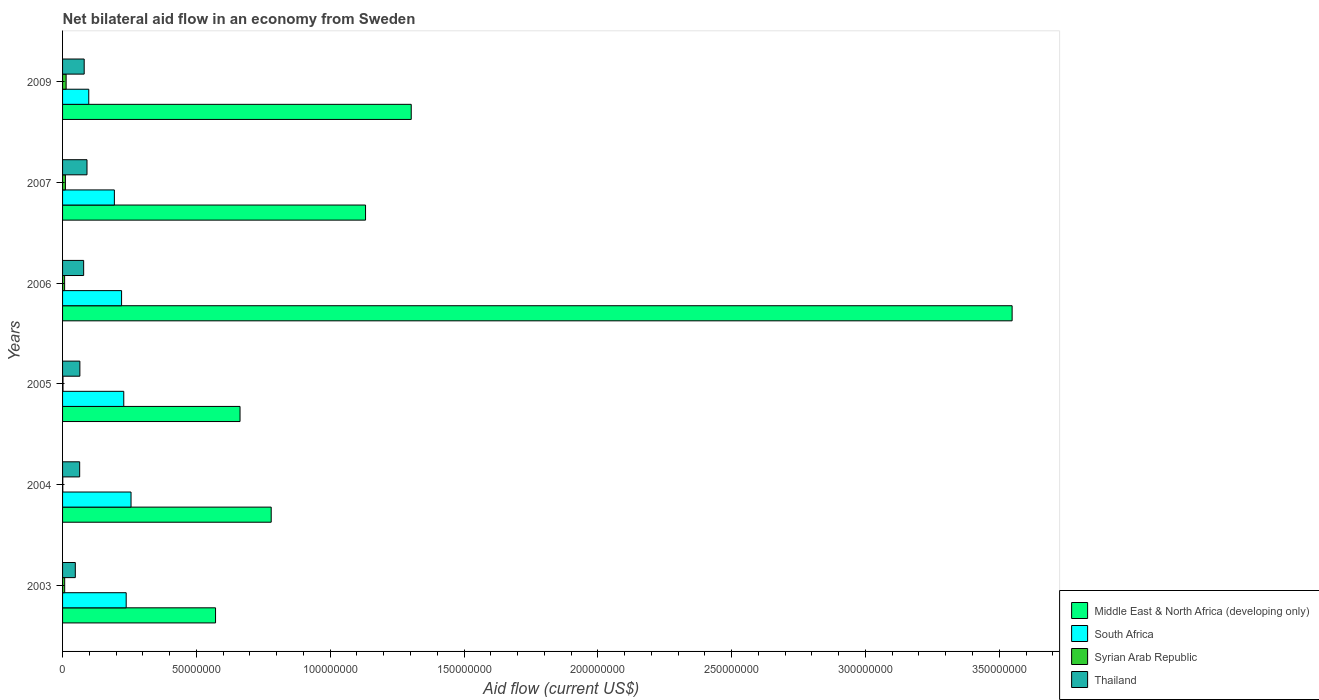How many different coloured bars are there?
Give a very brief answer. 4. Are the number of bars on each tick of the Y-axis equal?
Make the answer very short. Yes. What is the net bilateral aid flow in Middle East & North Africa (developing only) in 2004?
Offer a very short reply. 7.80e+07. Across all years, what is the maximum net bilateral aid flow in Syrian Arab Republic?
Your answer should be compact. 1.33e+06. Across all years, what is the minimum net bilateral aid flow in Syrian Arab Republic?
Offer a very short reply. 8.00e+04. In which year was the net bilateral aid flow in Syrian Arab Republic maximum?
Keep it short and to the point. 2009. In which year was the net bilateral aid flow in Middle East & North Africa (developing only) minimum?
Offer a very short reply. 2003. What is the total net bilateral aid flow in South Africa in the graph?
Keep it short and to the point. 1.23e+08. What is the difference between the net bilateral aid flow in Middle East & North Africa (developing only) in 2003 and that in 2007?
Give a very brief answer. -5.60e+07. What is the difference between the net bilateral aid flow in Middle East & North Africa (developing only) in 2004 and the net bilateral aid flow in Syrian Arab Republic in 2005?
Offer a terse response. 7.78e+07. What is the average net bilateral aid flow in Middle East & North Africa (developing only) per year?
Offer a very short reply. 1.33e+08. In the year 2003, what is the difference between the net bilateral aid flow in Thailand and net bilateral aid flow in Syrian Arab Republic?
Offer a terse response. 3.97e+06. What is the ratio of the net bilateral aid flow in Middle East & North Africa (developing only) in 2004 to that in 2009?
Your response must be concise. 0.6. Is the difference between the net bilateral aid flow in Thailand in 2004 and 2005 greater than the difference between the net bilateral aid flow in Syrian Arab Republic in 2004 and 2005?
Keep it short and to the point. No. What is the difference between the highest and the second highest net bilateral aid flow in South Africa?
Keep it short and to the point. 1.81e+06. What is the difference between the highest and the lowest net bilateral aid flow in Thailand?
Provide a succinct answer. 4.37e+06. Is it the case that in every year, the sum of the net bilateral aid flow in Syrian Arab Republic and net bilateral aid flow in Middle East & North Africa (developing only) is greater than the sum of net bilateral aid flow in Thailand and net bilateral aid flow in South Africa?
Make the answer very short. Yes. What does the 3rd bar from the top in 2003 represents?
Ensure brevity in your answer.  South Africa. What does the 3rd bar from the bottom in 2006 represents?
Your answer should be compact. Syrian Arab Republic. Is it the case that in every year, the sum of the net bilateral aid flow in Middle East & North Africa (developing only) and net bilateral aid flow in South Africa is greater than the net bilateral aid flow in Syrian Arab Republic?
Ensure brevity in your answer.  Yes. How many years are there in the graph?
Provide a short and direct response. 6. Does the graph contain any zero values?
Give a very brief answer. No. Where does the legend appear in the graph?
Make the answer very short. Bottom right. What is the title of the graph?
Provide a succinct answer. Net bilateral aid flow in an economy from Sweden. Does "Somalia" appear as one of the legend labels in the graph?
Your answer should be compact. No. What is the label or title of the X-axis?
Make the answer very short. Aid flow (current US$). What is the Aid flow (current US$) of Middle East & North Africa (developing only) in 2003?
Your response must be concise. 5.72e+07. What is the Aid flow (current US$) in South Africa in 2003?
Offer a very short reply. 2.38e+07. What is the Aid flow (current US$) in Syrian Arab Republic in 2003?
Offer a very short reply. 7.90e+05. What is the Aid flow (current US$) of Thailand in 2003?
Keep it short and to the point. 4.76e+06. What is the Aid flow (current US$) in Middle East & North Africa (developing only) in 2004?
Your answer should be compact. 7.80e+07. What is the Aid flow (current US$) of South Africa in 2004?
Your answer should be very brief. 2.56e+07. What is the Aid flow (current US$) in Syrian Arab Republic in 2004?
Provide a succinct answer. 8.00e+04. What is the Aid flow (current US$) of Thailand in 2004?
Your answer should be very brief. 6.39e+06. What is the Aid flow (current US$) in Middle East & North Africa (developing only) in 2005?
Offer a very short reply. 6.63e+07. What is the Aid flow (current US$) in South Africa in 2005?
Offer a very short reply. 2.29e+07. What is the Aid flow (current US$) in Thailand in 2005?
Provide a succinct answer. 6.47e+06. What is the Aid flow (current US$) in Middle East & North Africa (developing only) in 2006?
Offer a terse response. 3.55e+08. What is the Aid flow (current US$) of South Africa in 2006?
Offer a very short reply. 2.20e+07. What is the Aid flow (current US$) in Syrian Arab Republic in 2006?
Your response must be concise. 7.70e+05. What is the Aid flow (current US$) in Thailand in 2006?
Provide a succinct answer. 7.88e+06. What is the Aid flow (current US$) of Middle East & North Africa (developing only) in 2007?
Give a very brief answer. 1.13e+08. What is the Aid flow (current US$) in South Africa in 2007?
Your answer should be very brief. 1.94e+07. What is the Aid flow (current US$) in Syrian Arab Republic in 2007?
Ensure brevity in your answer.  1.06e+06. What is the Aid flow (current US$) in Thailand in 2007?
Your answer should be compact. 9.13e+06. What is the Aid flow (current US$) of Middle East & North Africa (developing only) in 2009?
Provide a short and direct response. 1.30e+08. What is the Aid flow (current US$) of South Africa in 2009?
Your answer should be very brief. 9.79e+06. What is the Aid flow (current US$) in Syrian Arab Republic in 2009?
Your response must be concise. 1.33e+06. What is the Aid flow (current US$) of Thailand in 2009?
Provide a succinct answer. 8.08e+06. Across all years, what is the maximum Aid flow (current US$) in Middle East & North Africa (developing only)?
Provide a succinct answer. 3.55e+08. Across all years, what is the maximum Aid flow (current US$) of South Africa?
Your answer should be compact. 2.56e+07. Across all years, what is the maximum Aid flow (current US$) of Syrian Arab Republic?
Offer a terse response. 1.33e+06. Across all years, what is the maximum Aid flow (current US$) of Thailand?
Your response must be concise. 9.13e+06. Across all years, what is the minimum Aid flow (current US$) in Middle East & North Africa (developing only)?
Provide a short and direct response. 5.72e+07. Across all years, what is the minimum Aid flow (current US$) in South Africa?
Your response must be concise. 9.79e+06. Across all years, what is the minimum Aid flow (current US$) of Syrian Arab Republic?
Offer a terse response. 8.00e+04. Across all years, what is the minimum Aid flow (current US$) in Thailand?
Offer a very short reply. 4.76e+06. What is the total Aid flow (current US$) of Middle East & North Africa (developing only) in the graph?
Offer a very short reply. 8.00e+08. What is the total Aid flow (current US$) in South Africa in the graph?
Your answer should be compact. 1.23e+08. What is the total Aid flow (current US$) in Syrian Arab Republic in the graph?
Provide a succinct answer. 4.19e+06. What is the total Aid flow (current US$) of Thailand in the graph?
Ensure brevity in your answer.  4.27e+07. What is the difference between the Aid flow (current US$) in Middle East & North Africa (developing only) in 2003 and that in 2004?
Offer a terse response. -2.08e+07. What is the difference between the Aid flow (current US$) in South Africa in 2003 and that in 2004?
Your response must be concise. -1.81e+06. What is the difference between the Aid flow (current US$) of Syrian Arab Republic in 2003 and that in 2004?
Your answer should be compact. 7.10e+05. What is the difference between the Aid flow (current US$) of Thailand in 2003 and that in 2004?
Your answer should be compact. -1.63e+06. What is the difference between the Aid flow (current US$) in Middle East & North Africa (developing only) in 2003 and that in 2005?
Keep it short and to the point. -9.15e+06. What is the difference between the Aid flow (current US$) of South Africa in 2003 and that in 2005?
Provide a short and direct response. 9.00e+05. What is the difference between the Aid flow (current US$) of Syrian Arab Republic in 2003 and that in 2005?
Offer a very short reply. 6.30e+05. What is the difference between the Aid flow (current US$) in Thailand in 2003 and that in 2005?
Your response must be concise. -1.71e+06. What is the difference between the Aid flow (current US$) of Middle East & North Africa (developing only) in 2003 and that in 2006?
Provide a short and direct response. -2.98e+08. What is the difference between the Aid flow (current US$) in South Africa in 2003 and that in 2006?
Provide a succinct answer. 1.72e+06. What is the difference between the Aid flow (current US$) in Thailand in 2003 and that in 2006?
Make the answer very short. -3.12e+06. What is the difference between the Aid flow (current US$) in Middle East & North Africa (developing only) in 2003 and that in 2007?
Keep it short and to the point. -5.60e+07. What is the difference between the Aid flow (current US$) of South Africa in 2003 and that in 2007?
Make the answer very short. 4.41e+06. What is the difference between the Aid flow (current US$) of Syrian Arab Republic in 2003 and that in 2007?
Your answer should be compact. -2.70e+05. What is the difference between the Aid flow (current US$) in Thailand in 2003 and that in 2007?
Keep it short and to the point. -4.37e+06. What is the difference between the Aid flow (current US$) of Middle East & North Africa (developing only) in 2003 and that in 2009?
Make the answer very short. -7.31e+07. What is the difference between the Aid flow (current US$) in South Africa in 2003 and that in 2009?
Ensure brevity in your answer.  1.40e+07. What is the difference between the Aid flow (current US$) of Syrian Arab Republic in 2003 and that in 2009?
Ensure brevity in your answer.  -5.40e+05. What is the difference between the Aid flow (current US$) in Thailand in 2003 and that in 2009?
Make the answer very short. -3.32e+06. What is the difference between the Aid flow (current US$) of Middle East & North Africa (developing only) in 2004 and that in 2005?
Keep it short and to the point. 1.16e+07. What is the difference between the Aid flow (current US$) in South Africa in 2004 and that in 2005?
Ensure brevity in your answer.  2.71e+06. What is the difference between the Aid flow (current US$) of Middle East & North Africa (developing only) in 2004 and that in 2006?
Ensure brevity in your answer.  -2.77e+08. What is the difference between the Aid flow (current US$) in South Africa in 2004 and that in 2006?
Provide a succinct answer. 3.53e+06. What is the difference between the Aid flow (current US$) of Syrian Arab Republic in 2004 and that in 2006?
Keep it short and to the point. -6.90e+05. What is the difference between the Aid flow (current US$) of Thailand in 2004 and that in 2006?
Your answer should be compact. -1.49e+06. What is the difference between the Aid flow (current US$) in Middle East & North Africa (developing only) in 2004 and that in 2007?
Your response must be concise. -3.52e+07. What is the difference between the Aid flow (current US$) in South Africa in 2004 and that in 2007?
Give a very brief answer. 6.22e+06. What is the difference between the Aid flow (current US$) in Syrian Arab Republic in 2004 and that in 2007?
Your response must be concise. -9.80e+05. What is the difference between the Aid flow (current US$) of Thailand in 2004 and that in 2007?
Provide a succinct answer. -2.74e+06. What is the difference between the Aid flow (current US$) in Middle East & North Africa (developing only) in 2004 and that in 2009?
Provide a short and direct response. -5.23e+07. What is the difference between the Aid flow (current US$) of South Africa in 2004 and that in 2009?
Your answer should be very brief. 1.58e+07. What is the difference between the Aid flow (current US$) in Syrian Arab Republic in 2004 and that in 2009?
Ensure brevity in your answer.  -1.25e+06. What is the difference between the Aid flow (current US$) in Thailand in 2004 and that in 2009?
Your response must be concise. -1.69e+06. What is the difference between the Aid flow (current US$) of Middle East & North Africa (developing only) in 2005 and that in 2006?
Offer a very short reply. -2.88e+08. What is the difference between the Aid flow (current US$) in South Africa in 2005 and that in 2006?
Your answer should be compact. 8.20e+05. What is the difference between the Aid flow (current US$) of Syrian Arab Republic in 2005 and that in 2006?
Ensure brevity in your answer.  -6.10e+05. What is the difference between the Aid flow (current US$) in Thailand in 2005 and that in 2006?
Your response must be concise. -1.41e+06. What is the difference between the Aid flow (current US$) of Middle East & North Africa (developing only) in 2005 and that in 2007?
Provide a short and direct response. -4.69e+07. What is the difference between the Aid flow (current US$) in South Africa in 2005 and that in 2007?
Provide a succinct answer. 3.51e+06. What is the difference between the Aid flow (current US$) of Syrian Arab Republic in 2005 and that in 2007?
Your answer should be compact. -9.00e+05. What is the difference between the Aid flow (current US$) of Thailand in 2005 and that in 2007?
Your answer should be compact. -2.66e+06. What is the difference between the Aid flow (current US$) of Middle East & North Africa (developing only) in 2005 and that in 2009?
Keep it short and to the point. -6.40e+07. What is the difference between the Aid flow (current US$) of South Africa in 2005 and that in 2009?
Provide a succinct answer. 1.31e+07. What is the difference between the Aid flow (current US$) in Syrian Arab Republic in 2005 and that in 2009?
Provide a succinct answer. -1.17e+06. What is the difference between the Aid flow (current US$) in Thailand in 2005 and that in 2009?
Your response must be concise. -1.61e+06. What is the difference between the Aid flow (current US$) of Middle East & North Africa (developing only) in 2006 and that in 2007?
Keep it short and to the point. 2.42e+08. What is the difference between the Aid flow (current US$) of South Africa in 2006 and that in 2007?
Provide a short and direct response. 2.69e+06. What is the difference between the Aid flow (current US$) in Thailand in 2006 and that in 2007?
Provide a succinct answer. -1.25e+06. What is the difference between the Aid flow (current US$) in Middle East & North Africa (developing only) in 2006 and that in 2009?
Your response must be concise. 2.25e+08. What is the difference between the Aid flow (current US$) of South Africa in 2006 and that in 2009?
Your response must be concise. 1.23e+07. What is the difference between the Aid flow (current US$) in Syrian Arab Republic in 2006 and that in 2009?
Provide a short and direct response. -5.60e+05. What is the difference between the Aid flow (current US$) of Middle East & North Africa (developing only) in 2007 and that in 2009?
Give a very brief answer. -1.71e+07. What is the difference between the Aid flow (current US$) of South Africa in 2007 and that in 2009?
Give a very brief answer. 9.57e+06. What is the difference between the Aid flow (current US$) of Syrian Arab Republic in 2007 and that in 2009?
Keep it short and to the point. -2.70e+05. What is the difference between the Aid flow (current US$) of Thailand in 2007 and that in 2009?
Keep it short and to the point. 1.05e+06. What is the difference between the Aid flow (current US$) in Middle East & North Africa (developing only) in 2003 and the Aid flow (current US$) in South Africa in 2004?
Offer a very short reply. 3.16e+07. What is the difference between the Aid flow (current US$) in Middle East & North Africa (developing only) in 2003 and the Aid flow (current US$) in Syrian Arab Republic in 2004?
Offer a terse response. 5.71e+07. What is the difference between the Aid flow (current US$) in Middle East & North Africa (developing only) in 2003 and the Aid flow (current US$) in Thailand in 2004?
Offer a very short reply. 5.08e+07. What is the difference between the Aid flow (current US$) of South Africa in 2003 and the Aid flow (current US$) of Syrian Arab Republic in 2004?
Your response must be concise. 2.37e+07. What is the difference between the Aid flow (current US$) of South Africa in 2003 and the Aid flow (current US$) of Thailand in 2004?
Your answer should be very brief. 1.74e+07. What is the difference between the Aid flow (current US$) of Syrian Arab Republic in 2003 and the Aid flow (current US$) of Thailand in 2004?
Ensure brevity in your answer.  -5.60e+06. What is the difference between the Aid flow (current US$) of Middle East & North Africa (developing only) in 2003 and the Aid flow (current US$) of South Africa in 2005?
Provide a short and direct response. 3.43e+07. What is the difference between the Aid flow (current US$) in Middle East & North Africa (developing only) in 2003 and the Aid flow (current US$) in Syrian Arab Republic in 2005?
Your answer should be very brief. 5.70e+07. What is the difference between the Aid flow (current US$) of Middle East & North Africa (developing only) in 2003 and the Aid flow (current US$) of Thailand in 2005?
Your answer should be compact. 5.07e+07. What is the difference between the Aid flow (current US$) of South Africa in 2003 and the Aid flow (current US$) of Syrian Arab Republic in 2005?
Your response must be concise. 2.36e+07. What is the difference between the Aid flow (current US$) in South Africa in 2003 and the Aid flow (current US$) in Thailand in 2005?
Make the answer very short. 1.73e+07. What is the difference between the Aid flow (current US$) in Syrian Arab Republic in 2003 and the Aid flow (current US$) in Thailand in 2005?
Offer a terse response. -5.68e+06. What is the difference between the Aid flow (current US$) in Middle East & North Africa (developing only) in 2003 and the Aid flow (current US$) in South Africa in 2006?
Your answer should be very brief. 3.51e+07. What is the difference between the Aid flow (current US$) in Middle East & North Africa (developing only) in 2003 and the Aid flow (current US$) in Syrian Arab Republic in 2006?
Provide a short and direct response. 5.64e+07. What is the difference between the Aid flow (current US$) of Middle East & North Africa (developing only) in 2003 and the Aid flow (current US$) of Thailand in 2006?
Give a very brief answer. 4.93e+07. What is the difference between the Aid flow (current US$) of South Africa in 2003 and the Aid flow (current US$) of Syrian Arab Republic in 2006?
Provide a succinct answer. 2.30e+07. What is the difference between the Aid flow (current US$) of South Africa in 2003 and the Aid flow (current US$) of Thailand in 2006?
Offer a very short reply. 1.59e+07. What is the difference between the Aid flow (current US$) of Syrian Arab Republic in 2003 and the Aid flow (current US$) of Thailand in 2006?
Your answer should be very brief. -7.09e+06. What is the difference between the Aid flow (current US$) in Middle East & North Africa (developing only) in 2003 and the Aid flow (current US$) in South Africa in 2007?
Keep it short and to the point. 3.78e+07. What is the difference between the Aid flow (current US$) of Middle East & North Africa (developing only) in 2003 and the Aid flow (current US$) of Syrian Arab Republic in 2007?
Ensure brevity in your answer.  5.61e+07. What is the difference between the Aid flow (current US$) of Middle East & North Africa (developing only) in 2003 and the Aid flow (current US$) of Thailand in 2007?
Offer a terse response. 4.80e+07. What is the difference between the Aid flow (current US$) of South Africa in 2003 and the Aid flow (current US$) of Syrian Arab Republic in 2007?
Make the answer very short. 2.27e+07. What is the difference between the Aid flow (current US$) in South Africa in 2003 and the Aid flow (current US$) in Thailand in 2007?
Ensure brevity in your answer.  1.46e+07. What is the difference between the Aid flow (current US$) of Syrian Arab Republic in 2003 and the Aid flow (current US$) of Thailand in 2007?
Provide a succinct answer. -8.34e+06. What is the difference between the Aid flow (current US$) in Middle East & North Africa (developing only) in 2003 and the Aid flow (current US$) in South Africa in 2009?
Provide a succinct answer. 4.74e+07. What is the difference between the Aid flow (current US$) of Middle East & North Africa (developing only) in 2003 and the Aid flow (current US$) of Syrian Arab Republic in 2009?
Offer a very short reply. 5.58e+07. What is the difference between the Aid flow (current US$) of Middle East & North Africa (developing only) in 2003 and the Aid flow (current US$) of Thailand in 2009?
Your answer should be compact. 4.91e+07. What is the difference between the Aid flow (current US$) of South Africa in 2003 and the Aid flow (current US$) of Syrian Arab Republic in 2009?
Give a very brief answer. 2.24e+07. What is the difference between the Aid flow (current US$) in South Africa in 2003 and the Aid flow (current US$) in Thailand in 2009?
Provide a short and direct response. 1.57e+07. What is the difference between the Aid flow (current US$) of Syrian Arab Republic in 2003 and the Aid flow (current US$) of Thailand in 2009?
Offer a terse response. -7.29e+06. What is the difference between the Aid flow (current US$) in Middle East & North Africa (developing only) in 2004 and the Aid flow (current US$) in South Africa in 2005?
Keep it short and to the point. 5.51e+07. What is the difference between the Aid flow (current US$) in Middle East & North Africa (developing only) in 2004 and the Aid flow (current US$) in Syrian Arab Republic in 2005?
Your answer should be very brief. 7.78e+07. What is the difference between the Aid flow (current US$) in Middle East & North Africa (developing only) in 2004 and the Aid flow (current US$) in Thailand in 2005?
Your answer should be very brief. 7.15e+07. What is the difference between the Aid flow (current US$) in South Africa in 2004 and the Aid flow (current US$) in Syrian Arab Republic in 2005?
Offer a terse response. 2.54e+07. What is the difference between the Aid flow (current US$) in South Africa in 2004 and the Aid flow (current US$) in Thailand in 2005?
Make the answer very short. 1.91e+07. What is the difference between the Aid flow (current US$) in Syrian Arab Republic in 2004 and the Aid flow (current US$) in Thailand in 2005?
Give a very brief answer. -6.39e+06. What is the difference between the Aid flow (current US$) of Middle East & North Africa (developing only) in 2004 and the Aid flow (current US$) of South Africa in 2006?
Your answer should be very brief. 5.59e+07. What is the difference between the Aid flow (current US$) of Middle East & North Africa (developing only) in 2004 and the Aid flow (current US$) of Syrian Arab Republic in 2006?
Make the answer very short. 7.72e+07. What is the difference between the Aid flow (current US$) in Middle East & North Africa (developing only) in 2004 and the Aid flow (current US$) in Thailand in 2006?
Offer a very short reply. 7.01e+07. What is the difference between the Aid flow (current US$) of South Africa in 2004 and the Aid flow (current US$) of Syrian Arab Republic in 2006?
Your answer should be compact. 2.48e+07. What is the difference between the Aid flow (current US$) of South Africa in 2004 and the Aid flow (current US$) of Thailand in 2006?
Provide a succinct answer. 1.77e+07. What is the difference between the Aid flow (current US$) of Syrian Arab Republic in 2004 and the Aid flow (current US$) of Thailand in 2006?
Make the answer very short. -7.80e+06. What is the difference between the Aid flow (current US$) of Middle East & North Africa (developing only) in 2004 and the Aid flow (current US$) of South Africa in 2007?
Keep it short and to the point. 5.86e+07. What is the difference between the Aid flow (current US$) in Middle East & North Africa (developing only) in 2004 and the Aid flow (current US$) in Syrian Arab Republic in 2007?
Offer a very short reply. 7.69e+07. What is the difference between the Aid flow (current US$) of Middle East & North Africa (developing only) in 2004 and the Aid flow (current US$) of Thailand in 2007?
Your response must be concise. 6.88e+07. What is the difference between the Aid flow (current US$) of South Africa in 2004 and the Aid flow (current US$) of Syrian Arab Republic in 2007?
Ensure brevity in your answer.  2.45e+07. What is the difference between the Aid flow (current US$) in South Africa in 2004 and the Aid flow (current US$) in Thailand in 2007?
Your response must be concise. 1.64e+07. What is the difference between the Aid flow (current US$) in Syrian Arab Republic in 2004 and the Aid flow (current US$) in Thailand in 2007?
Keep it short and to the point. -9.05e+06. What is the difference between the Aid flow (current US$) of Middle East & North Africa (developing only) in 2004 and the Aid flow (current US$) of South Africa in 2009?
Provide a succinct answer. 6.82e+07. What is the difference between the Aid flow (current US$) of Middle East & North Africa (developing only) in 2004 and the Aid flow (current US$) of Syrian Arab Republic in 2009?
Give a very brief answer. 7.66e+07. What is the difference between the Aid flow (current US$) of Middle East & North Africa (developing only) in 2004 and the Aid flow (current US$) of Thailand in 2009?
Provide a short and direct response. 6.99e+07. What is the difference between the Aid flow (current US$) in South Africa in 2004 and the Aid flow (current US$) in Syrian Arab Republic in 2009?
Provide a succinct answer. 2.42e+07. What is the difference between the Aid flow (current US$) in South Africa in 2004 and the Aid flow (current US$) in Thailand in 2009?
Your answer should be compact. 1.75e+07. What is the difference between the Aid flow (current US$) in Syrian Arab Republic in 2004 and the Aid flow (current US$) in Thailand in 2009?
Give a very brief answer. -8.00e+06. What is the difference between the Aid flow (current US$) of Middle East & North Africa (developing only) in 2005 and the Aid flow (current US$) of South Africa in 2006?
Ensure brevity in your answer.  4.43e+07. What is the difference between the Aid flow (current US$) in Middle East & North Africa (developing only) in 2005 and the Aid flow (current US$) in Syrian Arab Republic in 2006?
Ensure brevity in your answer.  6.55e+07. What is the difference between the Aid flow (current US$) of Middle East & North Africa (developing only) in 2005 and the Aid flow (current US$) of Thailand in 2006?
Give a very brief answer. 5.84e+07. What is the difference between the Aid flow (current US$) in South Africa in 2005 and the Aid flow (current US$) in Syrian Arab Republic in 2006?
Your answer should be very brief. 2.21e+07. What is the difference between the Aid flow (current US$) of South Africa in 2005 and the Aid flow (current US$) of Thailand in 2006?
Offer a terse response. 1.50e+07. What is the difference between the Aid flow (current US$) in Syrian Arab Republic in 2005 and the Aid flow (current US$) in Thailand in 2006?
Your response must be concise. -7.72e+06. What is the difference between the Aid flow (current US$) in Middle East & North Africa (developing only) in 2005 and the Aid flow (current US$) in South Africa in 2007?
Offer a terse response. 4.70e+07. What is the difference between the Aid flow (current US$) in Middle East & North Africa (developing only) in 2005 and the Aid flow (current US$) in Syrian Arab Republic in 2007?
Make the answer very short. 6.52e+07. What is the difference between the Aid flow (current US$) in Middle East & North Africa (developing only) in 2005 and the Aid flow (current US$) in Thailand in 2007?
Offer a terse response. 5.72e+07. What is the difference between the Aid flow (current US$) of South Africa in 2005 and the Aid flow (current US$) of Syrian Arab Republic in 2007?
Offer a terse response. 2.18e+07. What is the difference between the Aid flow (current US$) of South Africa in 2005 and the Aid flow (current US$) of Thailand in 2007?
Offer a terse response. 1.37e+07. What is the difference between the Aid flow (current US$) in Syrian Arab Republic in 2005 and the Aid flow (current US$) in Thailand in 2007?
Offer a very short reply. -8.97e+06. What is the difference between the Aid flow (current US$) in Middle East & North Africa (developing only) in 2005 and the Aid flow (current US$) in South Africa in 2009?
Provide a short and direct response. 5.65e+07. What is the difference between the Aid flow (current US$) of Middle East & North Africa (developing only) in 2005 and the Aid flow (current US$) of Syrian Arab Republic in 2009?
Provide a succinct answer. 6.50e+07. What is the difference between the Aid flow (current US$) of Middle East & North Africa (developing only) in 2005 and the Aid flow (current US$) of Thailand in 2009?
Offer a terse response. 5.82e+07. What is the difference between the Aid flow (current US$) in South Africa in 2005 and the Aid flow (current US$) in Syrian Arab Republic in 2009?
Give a very brief answer. 2.15e+07. What is the difference between the Aid flow (current US$) in South Africa in 2005 and the Aid flow (current US$) in Thailand in 2009?
Your answer should be compact. 1.48e+07. What is the difference between the Aid flow (current US$) of Syrian Arab Republic in 2005 and the Aid flow (current US$) of Thailand in 2009?
Your answer should be very brief. -7.92e+06. What is the difference between the Aid flow (current US$) in Middle East & North Africa (developing only) in 2006 and the Aid flow (current US$) in South Africa in 2007?
Keep it short and to the point. 3.35e+08. What is the difference between the Aid flow (current US$) in Middle East & North Africa (developing only) in 2006 and the Aid flow (current US$) in Syrian Arab Republic in 2007?
Provide a succinct answer. 3.54e+08. What is the difference between the Aid flow (current US$) in Middle East & North Africa (developing only) in 2006 and the Aid flow (current US$) in Thailand in 2007?
Provide a short and direct response. 3.46e+08. What is the difference between the Aid flow (current US$) of South Africa in 2006 and the Aid flow (current US$) of Syrian Arab Republic in 2007?
Ensure brevity in your answer.  2.10e+07. What is the difference between the Aid flow (current US$) of South Africa in 2006 and the Aid flow (current US$) of Thailand in 2007?
Ensure brevity in your answer.  1.29e+07. What is the difference between the Aid flow (current US$) of Syrian Arab Republic in 2006 and the Aid flow (current US$) of Thailand in 2007?
Offer a very short reply. -8.36e+06. What is the difference between the Aid flow (current US$) in Middle East & North Africa (developing only) in 2006 and the Aid flow (current US$) in South Africa in 2009?
Your response must be concise. 3.45e+08. What is the difference between the Aid flow (current US$) in Middle East & North Africa (developing only) in 2006 and the Aid flow (current US$) in Syrian Arab Republic in 2009?
Your answer should be compact. 3.53e+08. What is the difference between the Aid flow (current US$) in Middle East & North Africa (developing only) in 2006 and the Aid flow (current US$) in Thailand in 2009?
Keep it short and to the point. 3.47e+08. What is the difference between the Aid flow (current US$) of South Africa in 2006 and the Aid flow (current US$) of Syrian Arab Republic in 2009?
Ensure brevity in your answer.  2.07e+07. What is the difference between the Aid flow (current US$) of South Africa in 2006 and the Aid flow (current US$) of Thailand in 2009?
Your answer should be compact. 1.40e+07. What is the difference between the Aid flow (current US$) in Syrian Arab Republic in 2006 and the Aid flow (current US$) in Thailand in 2009?
Provide a short and direct response. -7.31e+06. What is the difference between the Aid flow (current US$) of Middle East & North Africa (developing only) in 2007 and the Aid flow (current US$) of South Africa in 2009?
Provide a short and direct response. 1.03e+08. What is the difference between the Aid flow (current US$) of Middle East & North Africa (developing only) in 2007 and the Aid flow (current US$) of Syrian Arab Republic in 2009?
Your answer should be compact. 1.12e+08. What is the difference between the Aid flow (current US$) in Middle East & North Africa (developing only) in 2007 and the Aid flow (current US$) in Thailand in 2009?
Keep it short and to the point. 1.05e+08. What is the difference between the Aid flow (current US$) of South Africa in 2007 and the Aid flow (current US$) of Syrian Arab Republic in 2009?
Your answer should be compact. 1.80e+07. What is the difference between the Aid flow (current US$) of South Africa in 2007 and the Aid flow (current US$) of Thailand in 2009?
Your answer should be compact. 1.13e+07. What is the difference between the Aid flow (current US$) in Syrian Arab Republic in 2007 and the Aid flow (current US$) in Thailand in 2009?
Give a very brief answer. -7.02e+06. What is the average Aid flow (current US$) in Middle East & North Africa (developing only) per year?
Keep it short and to the point. 1.33e+08. What is the average Aid flow (current US$) in South Africa per year?
Your answer should be very brief. 2.06e+07. What is the average Aid flow (current US$) in Syrian Arab Republic per year?
Your response must be concise. 6.98e+05. What is the average Aid flow (current US$) of Thailand per year?
Ensure brevity in your answer.  7.12e+06. In the year 2003, what is the difference between the Aid flow (current US$) of Middle East & North Africa (developing only) and Aid flow (current US$) of South Africa?
Your answer should be compact. 3.34e+07. In the year 2003, what is the difference between the Aid flow (current US$) in Middle East & North Africa (developing only) and Aid flow (current US$) in Syrian Arab Republic?
Your answer should be very brief. 5.64e+07. In the year 2003, what is the difference between the Aid flow (current US$) in Middle East & North Africa (developing only) and Aid flow (current US$) in Thailand?
Keep it short and to the point. 5.24e+07. In the year 2003, what is the difference between the Aid flow (current US$) in South Africa and Aid flow (current US$) in Syrian Arab Republic?
Give a very brief answer. 2.30e+07. In the year 2003, what is the difference between the Aid flow (current US$) in South Africa and Aid flow (current US$) in Thailand?
Give a very brief answer. 1.90e+07. In the year 2003, what is the difference between the Aid flow (current US$) in Syrian Arab Republic and Aid flow (current US$) in Thailand?
Give a very brief answer. -3.97e+06. In the year 2004, what is the difference between the Aid flow (current US$) in Middle East & North Africa (developing only) and Aid flow (current US$) in South Africa?
Your response must be concise. 5.24e+07. In the year 2004, what is the difference between the Aid flow (current US$) of Middle East & North Africa (developing only) and Aid flow (current US$) of Syrian Arab Republic?
Your answer should be very brief. 7.79e+07. In the year 2004, what is the difference between the Aid flow (current US$) of Middle East & North Africa (developing only) and Aid flow (current US$) of Thailand?
Provide a succinct answer. 7.16e+07. In the year 2004, what is the difference between the Aid flow (current US$) of South Africa and Aid flow (current US$) of Syrian Arab Republic?
Your answer should be very brief. 2.55e+07. In the year 2004, what is the difference between the Aid flow (current US$) in South Africa and Aid flow (current US$) in Thailand?
Your answer should be compact. 1.92e+07. In the year 2004, what is the difference between the Aid flow (current US$) of Syrian Arab Republic and Aid flow (current US$) of Thailand?
Provide a short and direct response. -6.31e+06. In the year 2005, what is the difference between the Aid flow (current US$) in Middle East & North Africa (developing only) and Aid flow (current US$) in South Africa?
Offer a very short reply. 4.34e+07. In the year 2005, what is the difference between the Aid flow (current US$) in Middle East & North Africa (developing only) and Aid flow (current US$) in Syrian Arab Republic?
Give a very brief answer. 6.62e+07. In the year 2005, what is the difference between the Aid flow (current US$) of Middle East & North Africa (developing only) and Aid flow (current US$) of Thailand?
Offer a terse response. 5.98e+07. In the year 2005, what is the difference between the Aid flow (current US$) in South Africa and Aid flow (current US$) in Syrian Arab Republic?
Your answer should be compact. 2.27e+07. In the year 2005, what is the difference between the Aid flow (current US$) in South Africa and Aid flow (current US$) in Thailand?
Make the answer very short. 1.64e+07. In the year 2005, what is the difference between the Aid flow (current US$) in Syrian Arab Republic and Aid flow (current US$) in Thailand?
Provide a short and direct response. -6.31e+06. In the year 2006, what is the difference between the Aid flow (current US$) of Middle East & North Africa (developing only) and Aid flow (current US$) of South Africa?
Provide a succinct answer. 3.33e+08. In the year 2006, what is the difference between the Aid flow (current US$) in Middle East & North Africa (developing only) and Aid flow (current US$) in Syrian Arab Republic?
Offer a terse response. 3.54e+08. In the year 2006, what is the difference between the Aid flow (current US$) in Middle East & North Africa (developing only) and Aid flow (current US$) in Thailand?
Offer a terse response. 3.47e+08. In the year 2006, what is the difference between the Aid flow (current US$) of South Africa and Aid flow (current US$) of Syrian Arab Republic?
Offer a terse response. 2.13e+07. In the year 2006, what is the difference between the Aid flow (current US$) of South Africa and Aid flow (current US$) of Thailand?
Offer a terse response. 1.42e+07. In the year 2006, what is the difference between the Aid flow (current US$) of Syrian Arab Republic and Aid flow (current US$) of Thailand?
Make the answer very short. -7.11e+06. In the year 2007, what is the difference between the Aid flow (current US$) in Middle East & North Africa (developing only) and Aid flow (current US$) in South Africa?
Ensure brevity in your answer.  9.38e+07. In the year 2007, what is the difference between the Aid flow (current US$) of Middle East & North Africa (developing only) and Aid flow (current US$) of Syrian Arab Republic?
Keep it short and to the point. 1.12e+08. In the year 2007, what is the difference between the Aid flow (current US$) in Middle East & North Africa (developing only) and Aid flow (current US$) in Thailand?
Keep it short and to the point. 1.04e+08. In the year 2007, what is the difference between the Aid flow (current US$) of South Africa and Aid flow (current US$) of Syrian Arab Republic?
Your response must be concise. 1.83e+07. In the year 2007, what is the difference between the Aid flow (current US$) of South Africa and Aid flow (current US$) of Thailand?
Provide a succinct answer. 1.02e+07. In the year 2007, what is the difference between the Aid flow (current US$) of Syrian Arab Republic and Aid flow (current US$) of Thailand?
Ensure brevity in your answer.  -8.07e+06. In the year 2009, what is the difference between the Aid flow (current US$) in Middle East & North Africa (developing only) and Aid flow (current US$) in South Africa?
Your response must be concise. 1.20e+08. In the year 2009, what is the difference between the Aid flow (current US$) in Middle East & North Africa (developing only) and Aid flow (current US$) in Syrian Arab Republic?
Provide a succinct answer. 1.29e+08. In the year 2009, what is the difference between the Aid flow (current US$) of Middle East & North Africa (developing only) and Aid flow (current US$) of Thailand?
Offer a terse response. 1.22e+08. In the year 2009, what is the difference between the Aid flow (current US$) of South Africa and Aid flow (current US$) of Syrian Arab Republic?
Make the answer very short. 8.46e+06. In the year 2009, what is the difference between the Aid flow (current US$) in South Africa and Aid flow (current US$) in Thailand?
Ensure brevity in your answer.  1.71e+06. In the year 2009, what is the difference between the Aid flow (current US$) of Syrian Arab Republic and Aid flow (current US$) of Thailand?
Offer a terse response. -6.75e+06. What is the ratio of the Aid flow (current US$) in Middle East & North Africa (developing only) in 2003 to that in 2004?
Your answer should be compact. 0.73. What is the ratio of the Aid flow (current US$) in South Africa in 2003 to that in 2004?
Offer a terse response. 0.93. What is the ratio of the Aid flow (current US$) of Syrian Arab Republic in 2003 to that in 2004?
Offer a terse response. 9.88. What is the ratio of the Aid flow (current US$) in Thailand in 2003 to that in 2004?
Keep it short and to the point. 0.74. What is the ratio of the Aid flow (current US$) in Middle East & North Africa (developing only) in 2003 to that in 2005?
Your response must be concise. 0.86. What is the ratio of the Aid flow (current US$) in South Africa in 2003 to that in 2005?
Give a very brief answer. 1.04. What is the ratio of the Aid flow (current US$) in Syrian Arab Republic in 2003 to that in 2005?
Make the answer very short. 4.94. What is the ratio of the Aid flow (current US$) in Thailand in 2003 to that in 2005?
Make the answer very short. 0.74. What is the ratio of the Aid flow (current US$) in Middle East & North Africa (developing only) in 2003 to that in 2006?
Give a very brief answer. 0.16. What is the ratio of the Aid flow (current US$) in South Africa in 2003 to that in 2006?
Your answer should be very brief. 1.08. What is the ratio of the Aid flow (current US$) in Thailand in 2003 to that in 2006?
Your response must be concise. 0.6. What is the ratio of the Aid flow (current US$) in Middle East & North Africa (developing only) in 2003 to that in 2007?
Make the answer very short. 0.5. What is the ratio of the Aid flow (current US$) in South Africa in 2003 to that in 2007?
Your answer should be very brief. 1.23. What is the ratio of the Aid flow (current US$) in Syrian Arab Republic in 2003 to that in 2007?
Make the answer very short. 0.75. What is the ratio of the Aid flow (current US$) in Thailand in 2003 to that in 2007?
Your answer should be compact. 0.52. What is the ratio of the Aid flow (current US$) in Middle East & North Africa (developing only) in 2003 to that in 2009?
Offer a very short reply. 0.44. What is the ratio of the Aid flow (current US$) in South Africa in 2003 to that in 2009?
Keep it short and to the point. 2.43. What is the ratio of the Aid flow (current US$) in Syrian Arab Republic in 2003 to that in 2009?
Provide a succinct answer. 0.59. What is the ratio of the Aid flow (current US$) of Thailand in 2003 to that in 2009?
Provide a succinct answer. 0.59. What is the ratio of the Aid flow (current US$) of Middle East & North Africa (developing only) in 2004 to that in 2005?
Offer a terse response. 1.18. What is the ratio of the Aid flow (current US$) of South Africa in 2004 to that in 2005?
Keep it short and to the point. 1.12. What is the ratio of the Aid flow (current US$) of Thailand in 2004 to that in 2005?
Provide a succinct answer. 0.99. What is the ratio of the Aid flow (current US$) in Middle East & North Africa (developing only) in 2004 to that in 2006?
Provide a short and direct response. 0.22. What is the ratio of the Aid flow (current US$) in South Africa in 2004 to that in 2006?
Give a very brief answer. 1.16. What is the ratio of the Aid flow (current US$) in Syrian Arab Republic in 2004 to that in 2006?
Provide a succinct answer. 0.1. What is the ratio of the Aid flow (current US$) in Thailand in 2004 to that in 2006?
Make the answer very short. 0.81. What is the ratio of the Aid flow (current US$) in Middle East & North Africa (developing only) in 2004 to that in 2007?
Offer a terse response. 0.69. What is the ratio of the Aid flow (current US$) of South Africa in 2004 to that in 2007?
Make the answer very short. 1.32. What is the ratio of the Aid flow (current US$) in Syrian Arab Republic in 2004 to that in 2007?
Offer a terse response. 0.08. What is the ratio of the Aid flow (current US$) of Thailand in 2004 to that in 2007?
Your answer should be very brief. 0.7. What is the ratio of the Aid flow (current US$) in Middle East & North Africa (developing only) in 2004 to that in 2009?
Give a very brief answer. 0.6. What is the ratio of the Aid flow (current US$) in South Africa in 2004 to that in 2009?
Your answer should be very brief. 2.61. What is the ratio of the Aid flow (current US$) of Syrian Arab Republic in 2004 to that in 2009?
Ensure brevity in your answer.  0.06. What is the ratio of the Aid flow (current US$) in Thailand in 2004 to that in 2009?
Provide a succinct answer. 0.79. What is the ratio of the Aid flow (current US$) in Middle East & North Africa (developing only) in 2005 to that in 2006?
Ensure brevity in your answer.  0.19. What is the ratio of the Aid flow (current US$) of South Africa in 2005 to that in 2006?
Your response must be concise. 1.04. What is the ratio of the Aid flow (current US$) in Syrian Arab Republic in 2005 to that in 2006?
Make the answer very short. 0.21. What is the ratio of the Aid flow (current US$) of Thailand in 2005 to that in 2006?
Your answer should be compact. 0.82. What is the ratio of the Aid flow (current US$) in Middle East & North Africa (developing only) in 2005 to that in 2007?
Provide a short and direct response. 0.59. What is the ratio of the Aid flow (current US$) in South Africa in 2005 to that in 2007?
Keep it short and to the point. 1.18. What is the ratio of the Aid flow (current US$) in Syrian Arab Republic in 2005 to that in 2007?
Offer a very short reply. 0.15. What is the ratio of the Aid flow (current US$) of Thailand in 2005 to that in 2007?
Your response must be concise. 0.71. What is the ratio of the Aid flow (current US$) in Middle East & North Africa (developing only) in 2005 to that in 2009?
Give a very brief answer. 0.51. What is the ratio of the Aid flow (current US$) of South Africa in 2005 to that in 2009?
Offer a very short reply. 2.34. What is the ratio of the Aid flow (current US$) in Syrian Arab Republic in 2005 to that in 2009?
Provide a short and direct response. 0.12. What is the ratio of the Aid flow (current US$) of Thailand in 2005 to that in 2009?
Make the answer very short. 0.8. What is the ratio of the Aid flow (current US$) of Middle East & North Africa (developing only) in 2006 to that in 2007?
Give a very brief answer. 3.13. What is the ratio of the Aid flow (current US$) in South Africa in 2006 to that in 2007?
Offer a terse response. 1.14. What is the ratio of the Aid flow (current US$) in Syrian Arab Republic in 2006 to that in 2007?
Offer a very short reply. 0.73. What is the ratio of the Aid flow (current US$) in Thailand in 2006 to that in 2007?
Offer a very short reply. 0.86. What is the ratio of the Aid flow (current US$) in Middle East & North Africa (developing only) in 2006 to that in 2009?
Ensure brevity in your answer.  2.72. What is the ratio of the Aid flow (current US$) of South Africa in 2006 to that in 2009?
Offer a terse response. 2.25. What is the ratio of the Aid flow (current US$) of Syrian Arab Republic in 2006 to that in 2009?
Make the answer very short. 0.58. What is the ratio of the Aid flow (current US$) in Thailand in 2006 to that in 2009?
Ensure brevity in your answer.  0.98. What is the ratio of the Aid flow (current US$) of Middle East & North Africa (developing only) in 2007 to that in 2009?
Ensure brevity in your answer.  0.87. What is the ratio of the Aid flow (current US$) of South Africa in 2007 to that in 2009?
Provide a succinct answer. 1.98. What is the ratio of the Aid flow (current US$) in Syrian Arab Republic in 2007 to that in 2009?
Offer a terse response. 0.8. What is the ratio of the Aid flow (current US$) of Thailand in 2007 to that in 2009?
Make the answer very short. 1.13. What is the difference between the highest and the second highest Aid flow (current US$) of Middle East & North Africa (developing only)?
Your response must be concise. 2.25e+08. What is the difference between the highest and the second highest Aid flow (current US$) in South Africa?
Your answer should be very brief. 1.81e+06. What is the difference between the highest and the second highest Aid flow (current US$) in Thailand?
Ensure brevity in your answer.  1.05e+06. What is the difference between the highest and the lowest Aid flow (current US$) in Middle East & North Africa (developing only)?
Make the answer very short. 2.98e+08. What is the difference between the highest and the lowest Aid flow (current US$) in South Africa?
Offer a terse response. 1.58e+07. What is the difference between the highest and the lowest Aid flow (current US$) in Syrian Arab Republic?
Your answer should be compact. 1.25e+06. What is the difference between the highest and the lowest Aid flow (current US$) in Thailand?
Ensure brevity in your answer.  4.37e+06. 